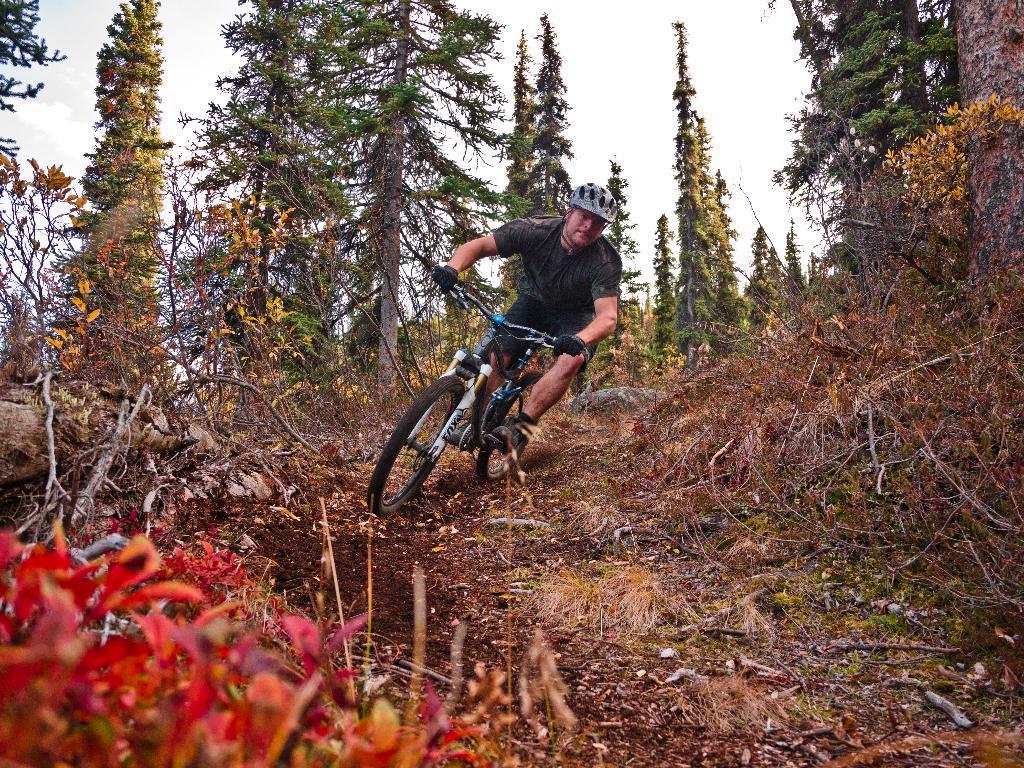In one or two sentences, can you explain what this image depicts? This image is clicked in a deep forest. There is a man riding bicycle and wearing helmet. He is also wearing a black t-shirt and a black short. In the background there are many tall trees. And to the front there is small plant which have red colored leaves. And to the right there is a dry grass. 